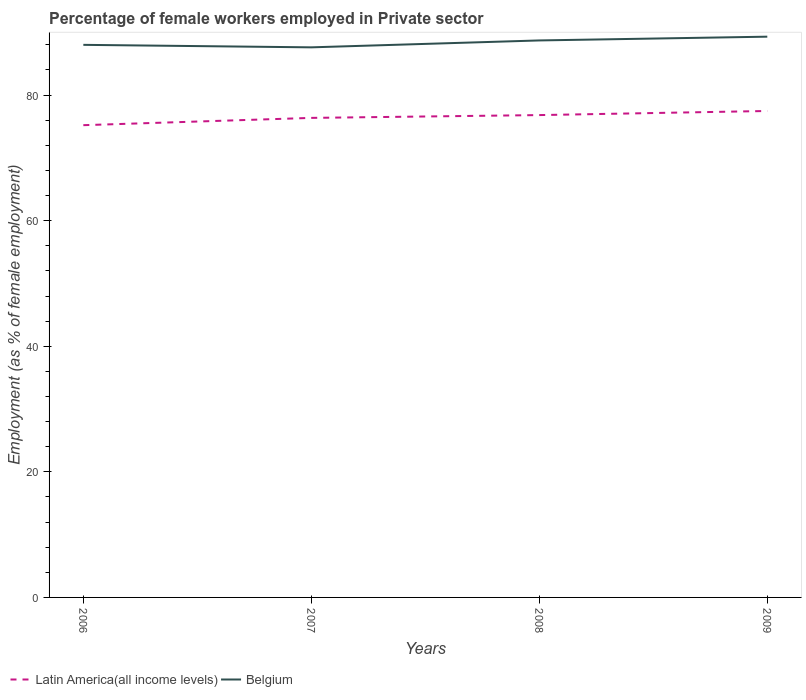How many different coloured lines are there?
Provide a succinct answer. 2. Does the line corresponding to Belgium intersect with the line corresponding to Latin America(all income levels)?
Offer a terse response. No. Is the number of lines equal to the number of legend labels?
Make the answer very short. Yes. Across all years, what is the maximum percentage of females employed in Private sector in Belgium?
Your answer should be very brief. 87.6. What is the total percentage of females employed in Private sector in Latin America(all income levels) in the graph?
Give a very brief answer. -1.1. What is the difference between the highest and the second highest percentage of females employed in Private sector in Belgium?
Give a very brief answer. 1.7. How many years are there in the graph?
Your answer should be compact. 4. Does the graph contain any zero values?
Your response must be concise. No. How many legend labels are there?
Provide a succinct answer. 2. How are the legend labels stacked?
Offer a terse response. Horizontal. What is the title of the graph?
Ensure brevity in your answer.  Percentage of female workers employed in Private sector. Does "Finland" appear as one of the legend labels in the graph?
Ensure brevity in your answer.  No. What is the label or title of the X-axis?
Offer a very short reply. Years. What is the label or title of the Y-axis?
Offer a terse response. Employment (as % of female employment). What is the Employment (as % of female employment) of Latin America(all income levels) in 2006?
Give a very brief answer. 75.21. What is the Employment (as % of female employment) of Latin America(all income levels) in 2007?
Give a very brief answer. 76.37. What is the Employment (as % of female employment) of Belgium in 2007?
Give a very brief answer. 87.6. What is the Employment (as % of female employment) of Latin America(all income levels) in 2008?
Give a very brief answer. 76.81. What is the Employment (as % of female employment) of Belgium in 2008?
Offer a very short reply. 88.7. What is the Employment (as % of female employment) in Latin America(all income levels) in 2009?
Provide a short and direct response. 77.47. What is the Employment (as % of female employment) in Belgium in 2009?
Offer a very short reply. 89.3. Across all years, what is the maximum Employment (as % of female employment) in Latin America(all income levels)?
Provide a succinct answer. 77.47. Across all years, what is the maximum Employment (as % of female employment) of Belgium?
Ensure brevity in your answer.  89.3. Across all years, what is the minimum Employment (as % of female employment) of Latin America(all income levels)?
Your response must be concise. 75.21. Across all years, what is the minimum Employment (as % of female employment) in Belgium?
Your answer should be compact. 87.6. What is the total Employment (as % of female employment) of Latin America(all income levels) in the graph?
Provide a succinct answer. 305.85. What is the total Employment (as % of female employment) in Belgium in the graph?
Make the answer very short. 353.6. What is the difference between the Employment (as % of female employment) in Latin America(all income levels) in 2006 and that in 2007?
Your answer should be compact. -1.16. What is the difference between the Employment (as % of female employment) of Latin America(all income levels) in 2006 and that in 2008?
Ensure brevity in your answer.  -1.61. What is the difference between the Employment (as % of female employment) in Latin America(all income levels) in 2006 and that in 2009?
Keep it short and to the point. -2.26. What is the difference between the Employment (as % of female employment) of Latin America(all income levels) in 2007 and that in 2008?
Give a very brief answer. -0.45. What is the difference between the Employment (as % of female employment) in Latin America(all income levels) in 2007 and that in 2009?
Your answer should be compact. -1.1. What is the difference between the Employment (as % of female employment) in Belgium in 2007 and that in 2009?
Offer a very short reply. -1.7. What is the difference between the Employment (as % of female employment) of Latin America(all income levels) in 2008 and that in 2009?
Offer a terse response. -0.65. What is the difference between the Employment (as % of female employment) in Latin America(all income levels) in 2006 and the Employment (as % of female employment) in Belgium in 2007?
Offer a terse response. -12.39. What is the difference between the Employment (as % of female employment) in Latin America(all income levels) in 2006 and the Employment (as % of female employment) in Belgium in 2008?
Provide a short and direct response. -13.49. What is the difference between the Employment (as % of female employment) of Latin America(all income levels) in 2006 and the Employment (as % of female employment) of Belgium in 2009?
Your response must be concise. -14.09. What is the difference between the Employment (as % of female employment) of Latin America(all income levels) in 2007 and the Employment (as % of female employment) of Belgium in 2008?
Give a very brief answer. -12.33. What is the difference between the Employment (as % of female employment) in Latin America(all income levels) in 2007 and the Employment (as % of female employment) in Belgium in 2009?
Make the answer very short. -12.93. What is the difference between the Employment (as % of female employment) of Latin America(all income levels) in 2008 and the Employment (as % of female employment) of Belgium in 2009?
Offer a very short reply. -12.49. What is the average Employment (as % of female employment) of Latin America(all income levels) per year?
Keep it short and to the point. 76.46. What is the average Employment (as % of female employment) of Belgium per year?
Offer a very short reply. 88.4. In the year 2006, what is the difference between the Employment (as % of female employment) of Latin America(all income levels) and Employment (as % of female employment) of Belgium?
Offer a terse response. -12.79. In the year 2007, what is the difference between the Employment (as % of female employment) of Latin America(all income levels) and Employment (as % of female employment) of Belgium?
Provide a short and direct response. -11.23. In the year 2008, what is the difference between the Employment (as % of female employment) in Latin America(all income levels) and Employment (as % of female employment) in Belgium?
Offer a very short reply. -11.89. In the year 2009, what is the difference between the Employment (as % of female employment) in Latin America(all income levels) and Employment (as % of female employment) in Belgium?
Your response must be concise. -11.83. What is the ratio of the Employment (as % of female employment) in Latin America(all income levels) in 2006 to that in 2007?
Your answer should be very brief. 0.98. What is the ratio of the Employment (as % of female employment) of Belgium in 2006 to that in 2007?
Offer a terse response. 1. What is the ratio of the Employment (as % of female employment) in Latin America(all income levels) in 2006 to that in 2008?
Your answer should be compact. 0.98. What is the ratio of the Employment (as % of female employment) in Latin America(all income levels) in 2006 to that in 2009?
Provide a succinct answer. 0.97. What is the ratio of the Employment (as % of female employment) of Belgium in 2006 to that in 2009?
Give a very brief answer. 0.99. What is the ratio of the Employment (as % of female employment) of Belgium in 2007 to that in 2008?
Ensure brevity in your answer.  0.99. What is the ratio of the Employment (as % of female employment) of Latin America(all income levels) in 2007 to that in 2009?
Your answer should be very brief. 0.99. What is the ratio of the Employment (as % of female employment) in Belgium in 2007 to that in 2009?
Give a very brief answer. 0.98. What is the difference between the highest and the second highest Employment (as % of female employment) of Latin America(all income levels)?
Your answer should be very brief. 0.65. What is the difference between the highest and the second highest Employment (as % of female employment) in Belgium?
Offer a very short reply. 0.6. What is the difference between the highest and the lowest Employment (as % of female employment) of Latin America(all income levels)?
Your answer should be compact. 2.26. What is the difference between the highest and the lowest Employment (as % of female employment) of Belgium?
Keep it short and to the point. 1.7. 